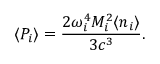<formula> <loc_0><loc_0><loc_500><loc_500>\langle P _ { i } \rangle = \frac { 2 \omega _ { i } ^ { 4 } M _ { i } ^ { 2 } \langle n _ { i } \rangle } { 3 c ^ { 3 } } .</formula> 